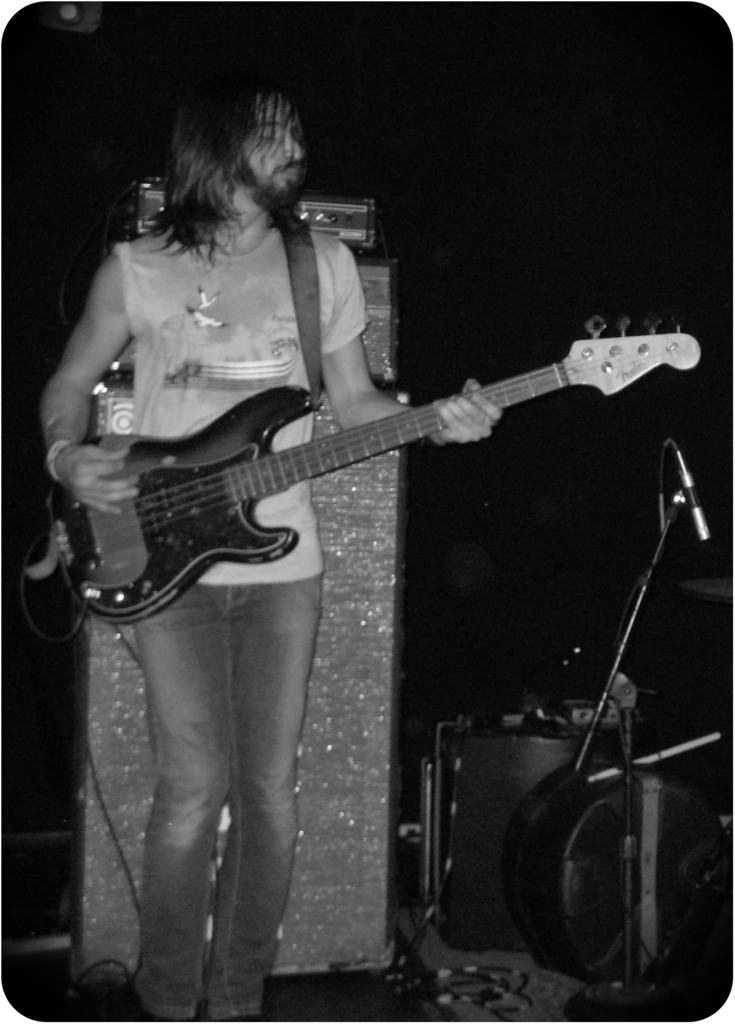What is the man in the image doing? The man is playing the guitar. What object is the man holding in the image? The man is holding a guitar. What can be seen in the background of the image? There is a microphone and a microphone stand in the background of the image. What type of berry is the man eating while playing the guitar in the image? There is no berry present in the image, and the man is not eating anything while playing the guitar. 